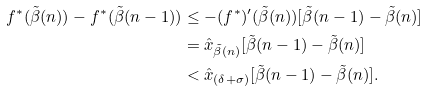<formula> <loc_0><loc_0><loc_500><loc_500>f ^ { * } ( \tilde { \beta } ( n ) ) - f ^ { * } ( \tilde { \beta } ( n - 1 ) ) & \leq - ( f ^ { * } ) ^ { \prime } ( \tilde { \beta } ( n ) ) [ \tilde { \beta } ( n - 1 ) - \tilde { \beta } ( n ) ] \\ & = \hat { x } _ { \tilde { \beta } ( n ) } [ \tilde { \beta } ( n - 1 ) - \tilde { \beta } ( n ) ] \\ & < \hat { x } _ { ( \delta + \sigma ) } [ \tilde { \beta } ( n - 1 ) - \tilde { \beta } ( n ) ] .</formula> 